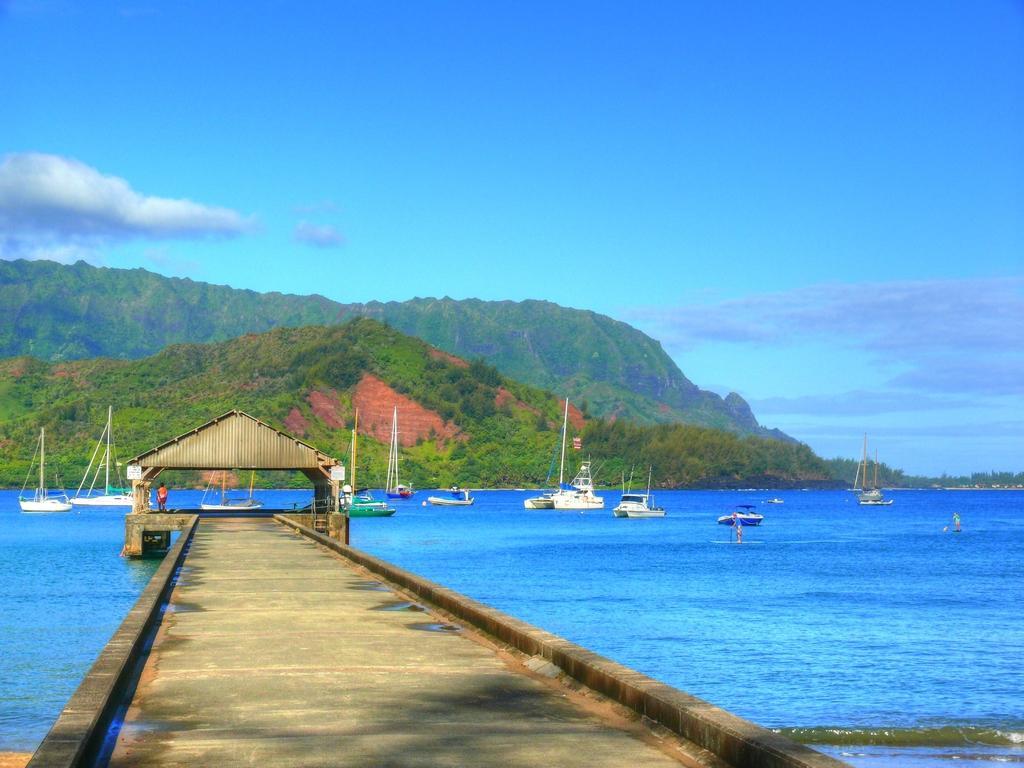In one or two sentences, can you explain what this image depicts? In this image, there are a few people. We can see a path above the water. We can also see a house. There are a few ships sailing on the water. We can see some hills. There are a few trees. We can also see the sky with clouds. 